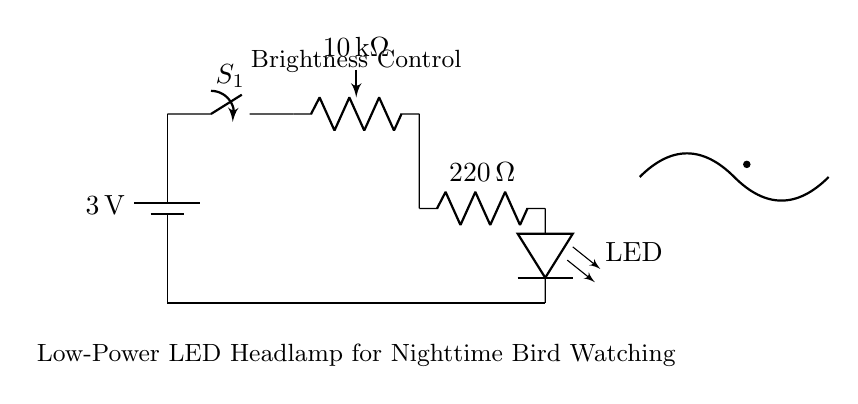What is the voltage of the battery in this circuit? The voltage of the battery is labeled as 3 volts. This is the power source for the entire circuit.
Answer: 3 volts What type of component is used for brightness control? A potentiometer, indicated by the symbol with a variable resistor, is used for brightness control in the circuit. It allows the user to adjust the resistance, thereby controlling the brightness of the LED.
Answer: Potentiometer How many ohms is the resistor in this circuit? The resistor is labeled as 220 ohms, which provides current limiting for the LED to prevent it from being damaged by excessive current.
Answer: 220 ohms What is the purpose of the switch in this circuit? The switch allows the user to turn the circuit on or off. When closed, it completes the circuit, allowing current to flow from the battery to the LED. When open, it interrupts the current flow.
Answer: On/Off control What will happen if the potentiometer is turned to maximum resistance? If the potentiometer is turned to maximum resistance, the current flowing through the circuit decreases, resulting in the LED turning dimmer or possibly off, depending on the maximum resistance.
Answer: LED dims Why is a low-power LED used in this circuit? A low-power LED is used to minimize energy consumption, which is essential for battery-operated devices like this headlamp, allowing for extended usage during nighttime bird watching without quickly draining the battery.
Answer: Energy efficiency 